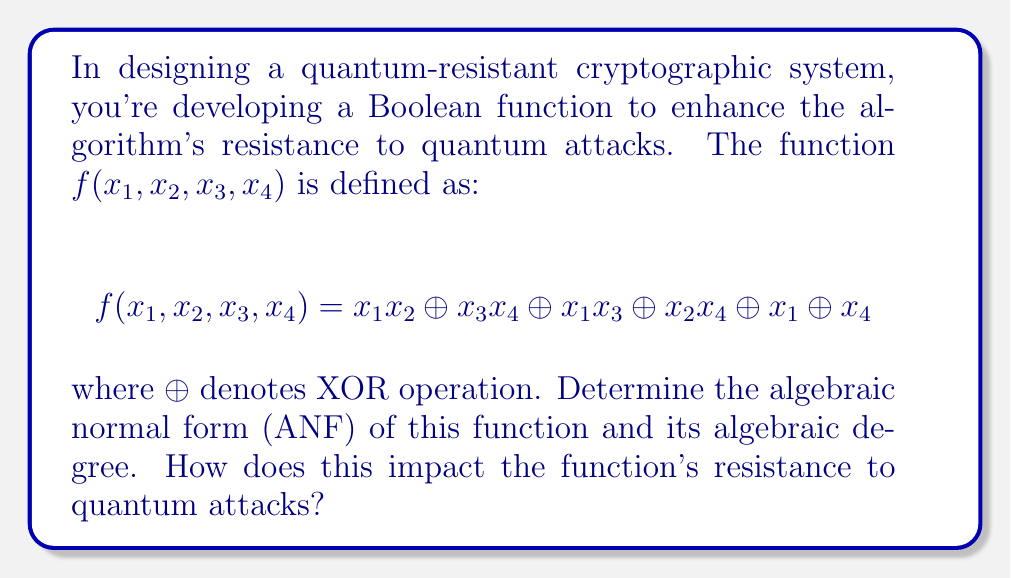Give your solution to this math problem. To solve this problem, we'll follow these steps:

1) First, we need to expand the function into its algebraic normal form (ANF). The ANF is a canonical representation of Boolean functions as a sum (XOR) of products.

2) In the given function, we already have products of variables and XOR operations, which is close to the ANF. We just need to distribute the terms:

   $f(x_1, x_2, x_3, x_4) = x_1x_2 \oplus x_3x_4 \oplus x_1x_3 \oplus x_2x_4 \oplus x_1 \oplus x_4$

3) This is already in ANF form, as each term is a product of variables (or a single variable) and all terms are XORed together.

4) To determine the algebraic degree, we look at the term with the highest number of variables multiplied together:

   - $x_1x_2$, $x_3x_4$, $x_1x_3$, and $x_2x_4$ all have degree 2
   - $x_1$ and $x_4$ have degree 1

5) Therefore, the algebraic degree of this function is 2.

6) The impact on quantum resistance:

   - The algebraic degree is an important measure of a Boolean function's complexity.
   - Higher algebraic degrees generally provide better resistance against quantum attacks, particularly algebraic attacks.
   - A degree of 2 is relatively low, which might make the function more vulnerable to certain quantum attacks.
   - However, the overall resistance depends on how this function is used within the larger cryptographic system.
   - To enhance quantum resistance, one might consider using functions with higher algebraic degrees or combining this function with other cryptographic primitives.
Answer: ANF: $x_1x_2 \oplus x_3x_4 \oplus x_1x_3 \oplus x_2x_4 \oplus x_1 \oplus x_4$, Degree: 2 